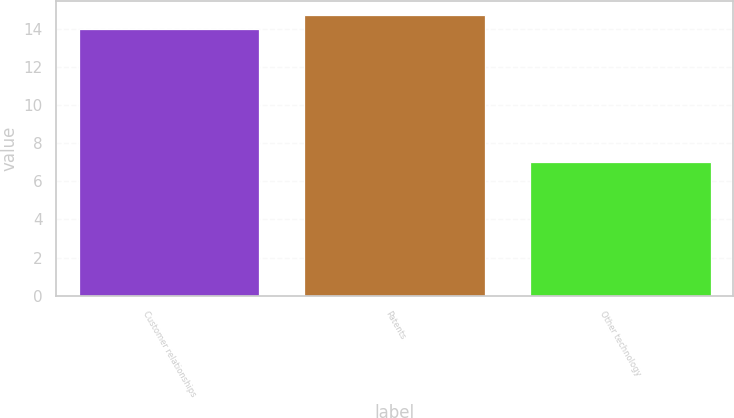Convert chart. <chart><loc_0><loc_0><loc_500><loc_500><bar_chart><fcel>Customer relationships<fcel>Patents<fcel>Other technology<nl><fcel>14<fcel>14.7<fcel>7<nl></chart> 